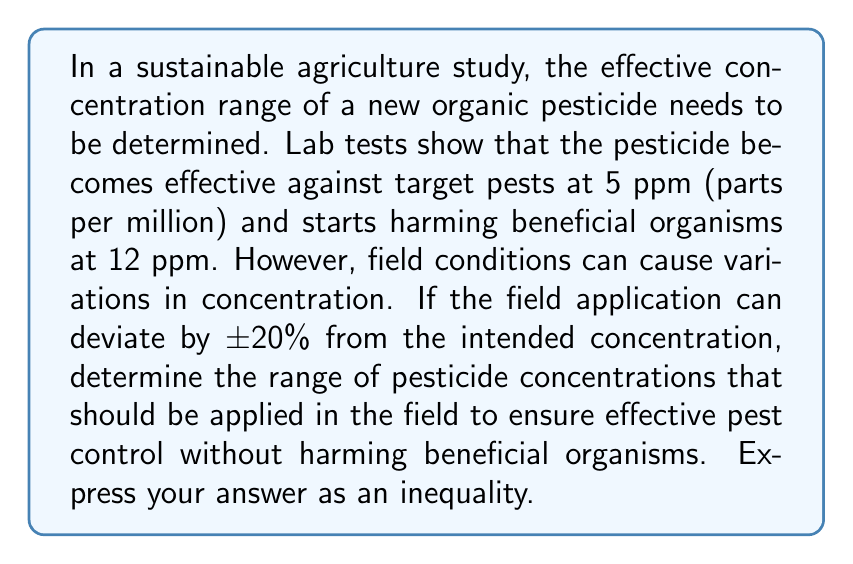Teach me how to tackle this problem. To solve this problem, we need to follow these steps:

1. Identify the key concentrations:
   - Minimum effective concentration against pests: 5 ppm
   - Maximum safe concentration for beneficial organisms: 12 ppm

2. Account for the ±20% variation in field conditions:
   - Lower bound: We need to ensure that even with a 20% decrease, the concentration remains at least 5 ppm.
   - Upper bound: We need to ensure that even with a 20% increase, the concentration doesn't exceed 12 ppm.

3. Calculate the lower bound:
   Let $x$ be the applied concentration.
   $x - 0.2x \geq 5$
   $0.8x \geq 5$
   $x \geq \frac{5}{0.8} = 6.25$

4. Calculate the upper bound:
   $x + 0.2x \leq 12$
   $1.2x \leq 12$
   $x \leq \frac{12}{1.2} = 10$

5. Combine the inequalities:
   $6.25 \leq x \leq 10$

This inequality represents the range of concentrations that should be applied in the field to ensure effectiveness against pests and safety for beneficial organisms, accounting for the ±20% variation in field conditions.
Answer: $6.25 \leq x \leq 10$, where $x$ is the applied pesticide concentration in ppm. 